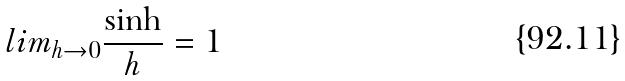Convert formula to latex. <formula><loc_0><loc_0><loc_500><loc_500>l i m _ { h \rightarrow 0 } \frac { \sinh } { h } = 1</formula> 